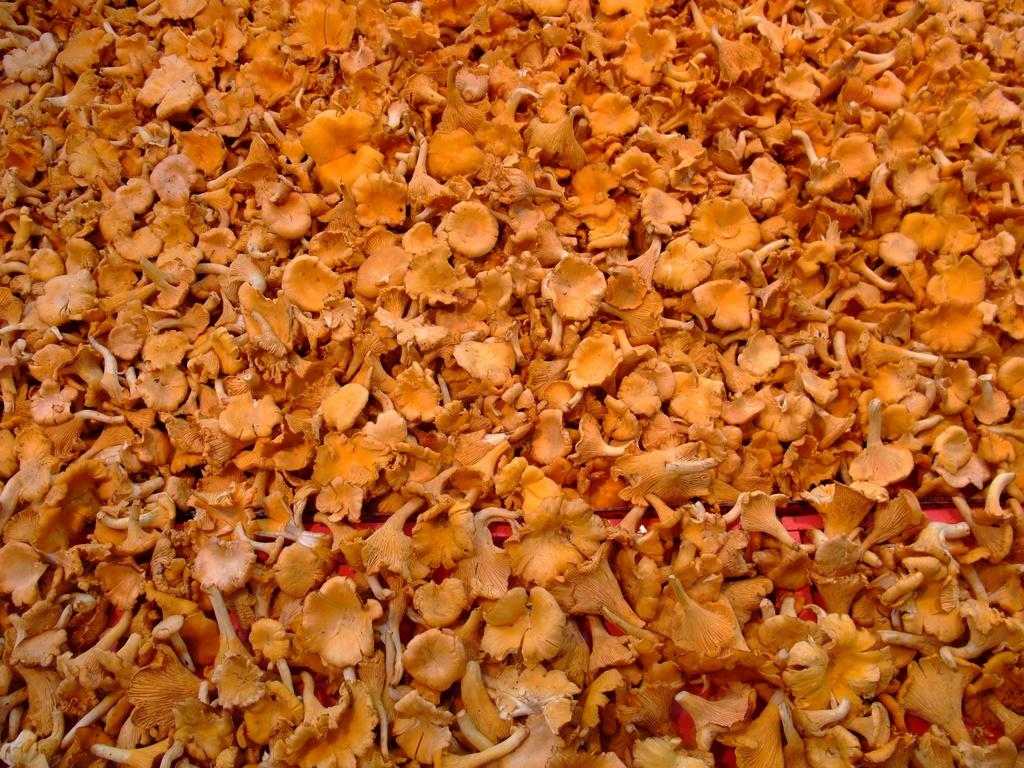What is the main subject of the image? The main subject of the image is a group of flowers. What can be said about the color of the flowers? The flowers are orange in color. What arithmetic problem can be solved using the flowers in the image? There is no arithmetic problem present in the image, as it features a group of orange flowers. What hobbies can be pursued using the flowers in the image? The image does not depict any hobbies or activities related to the flowers; it simply shows a group of orange flowers. 